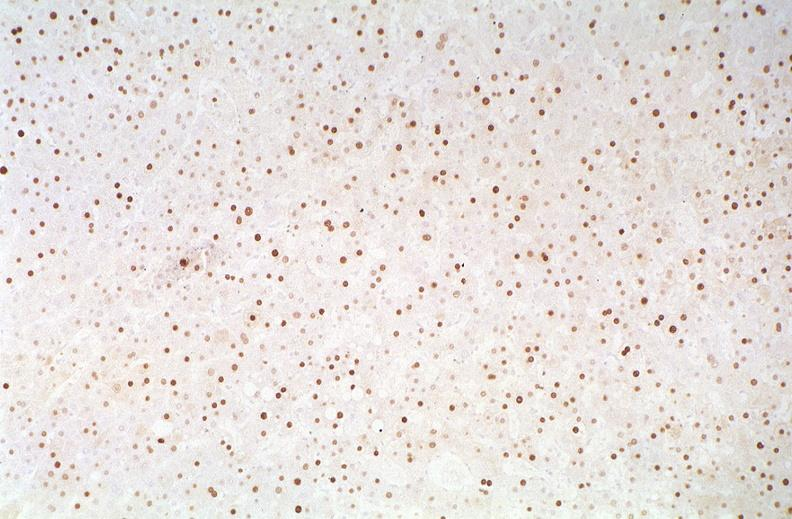does malignant thymoma show hepatitis b virus, hbve antigen immunohistochemistry?
Answer the question using a single word or phrase. No 